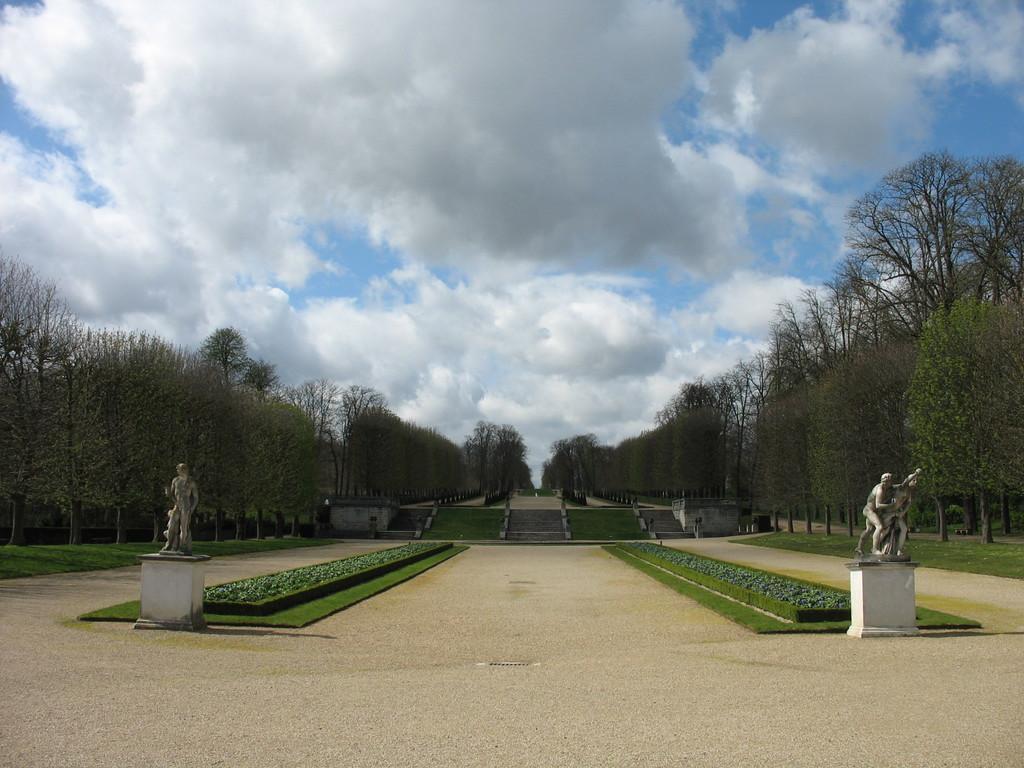In one or two sentences, can you explain what this image depicts? In this picture we can see sculptures, staircases, glass and around we can see some trees. 